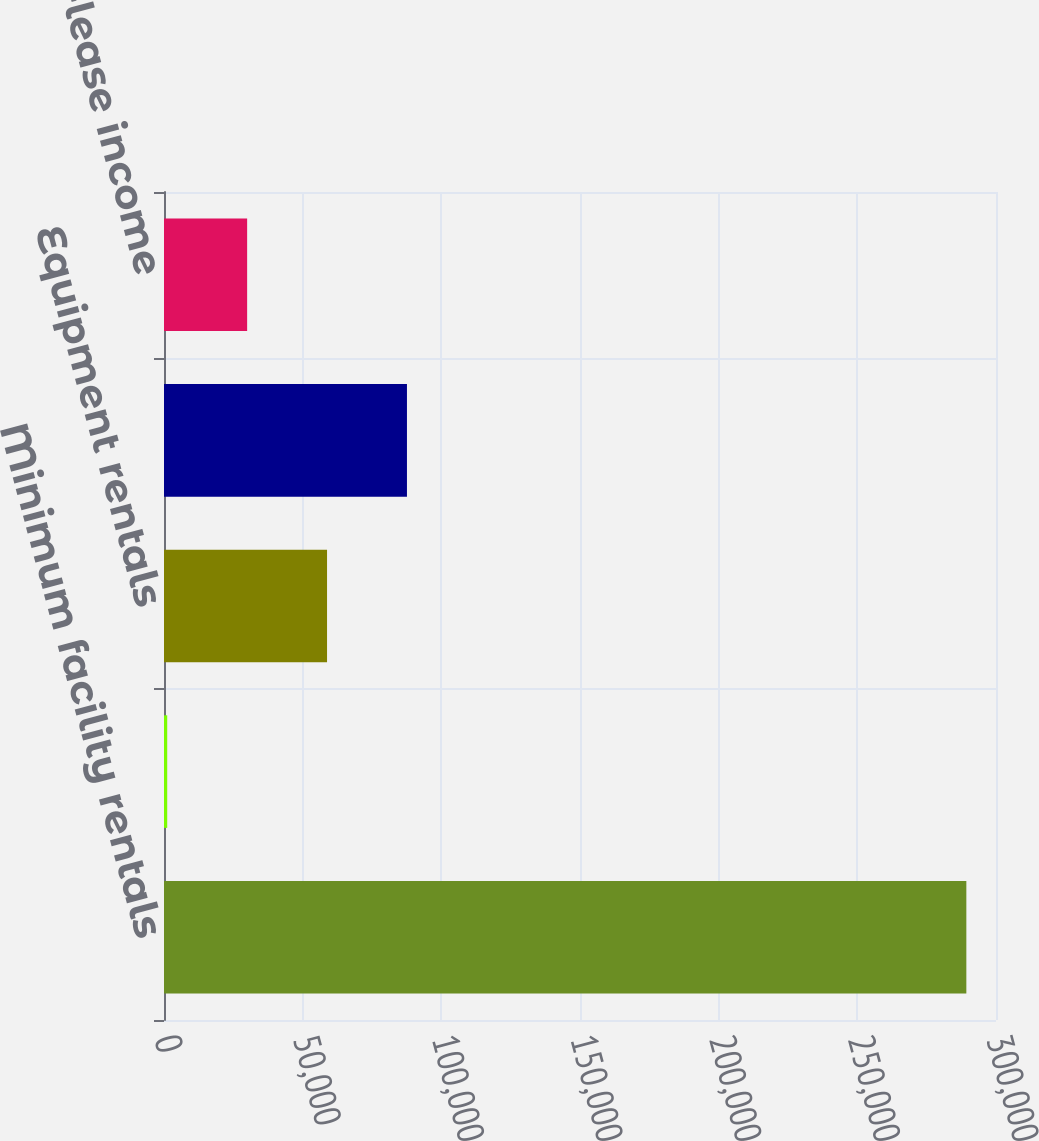<chart> <loc_0><loc_0><loc_500><loc_500><bar_chart><fcel>Minimum facility rentals<fcel>Contingency facility rentals<fcel>Equipment rentals<fcel>Vehicle rentals<fcel>Less Sub-lease income<nl><fcel>289306<fcel>1162<fcel>58790.8<fcel>87605.2<fcel>29976.4<nl></chart> 